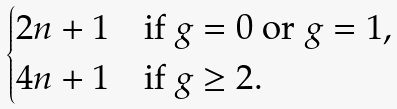Convert formula to latex. <formula><loc_0><loc_0><loc_500><loc_500>\begin{cases} 2 n + 1 & \text {if $g=0$ or $g=1$,} \\ 4 n + 1 & \text {if $g\geq 2$} . \end{cases}</formula> 